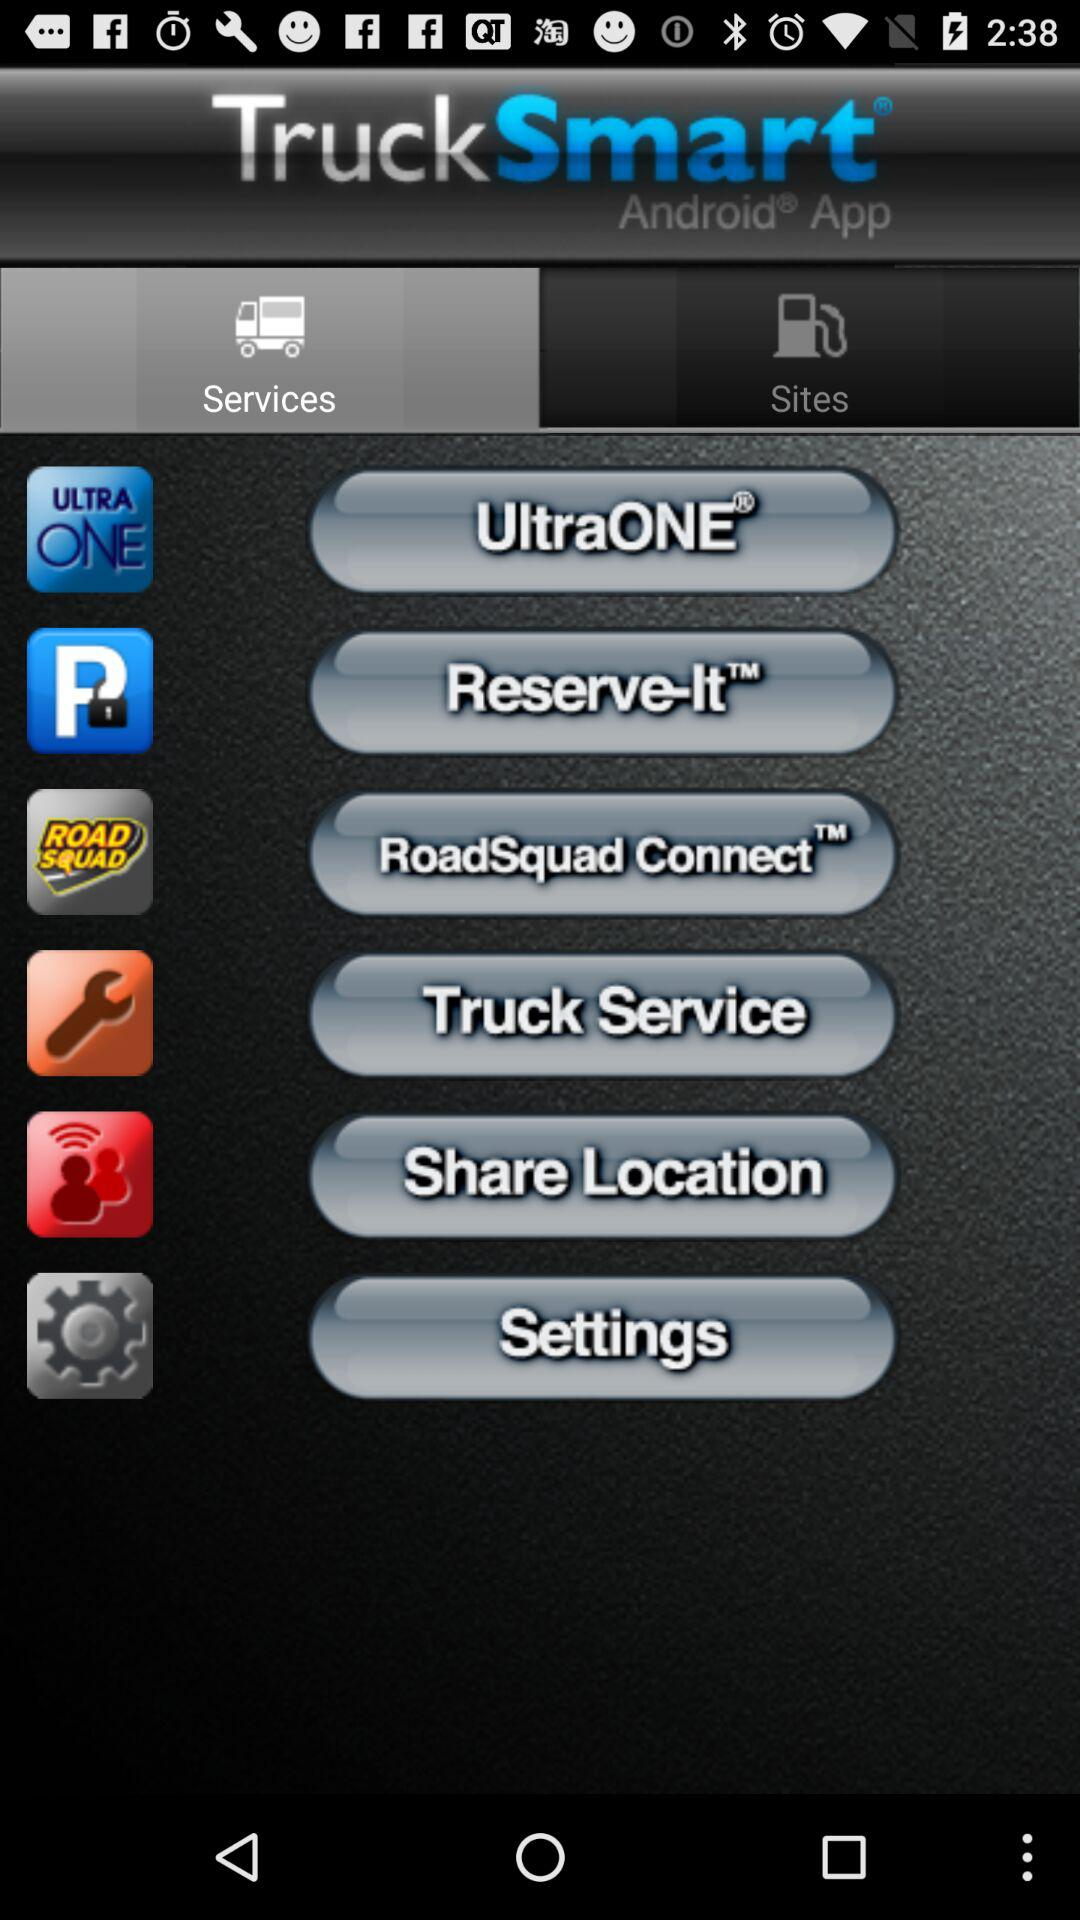What is the name of the application? The name of the application is "TruckSmart". 